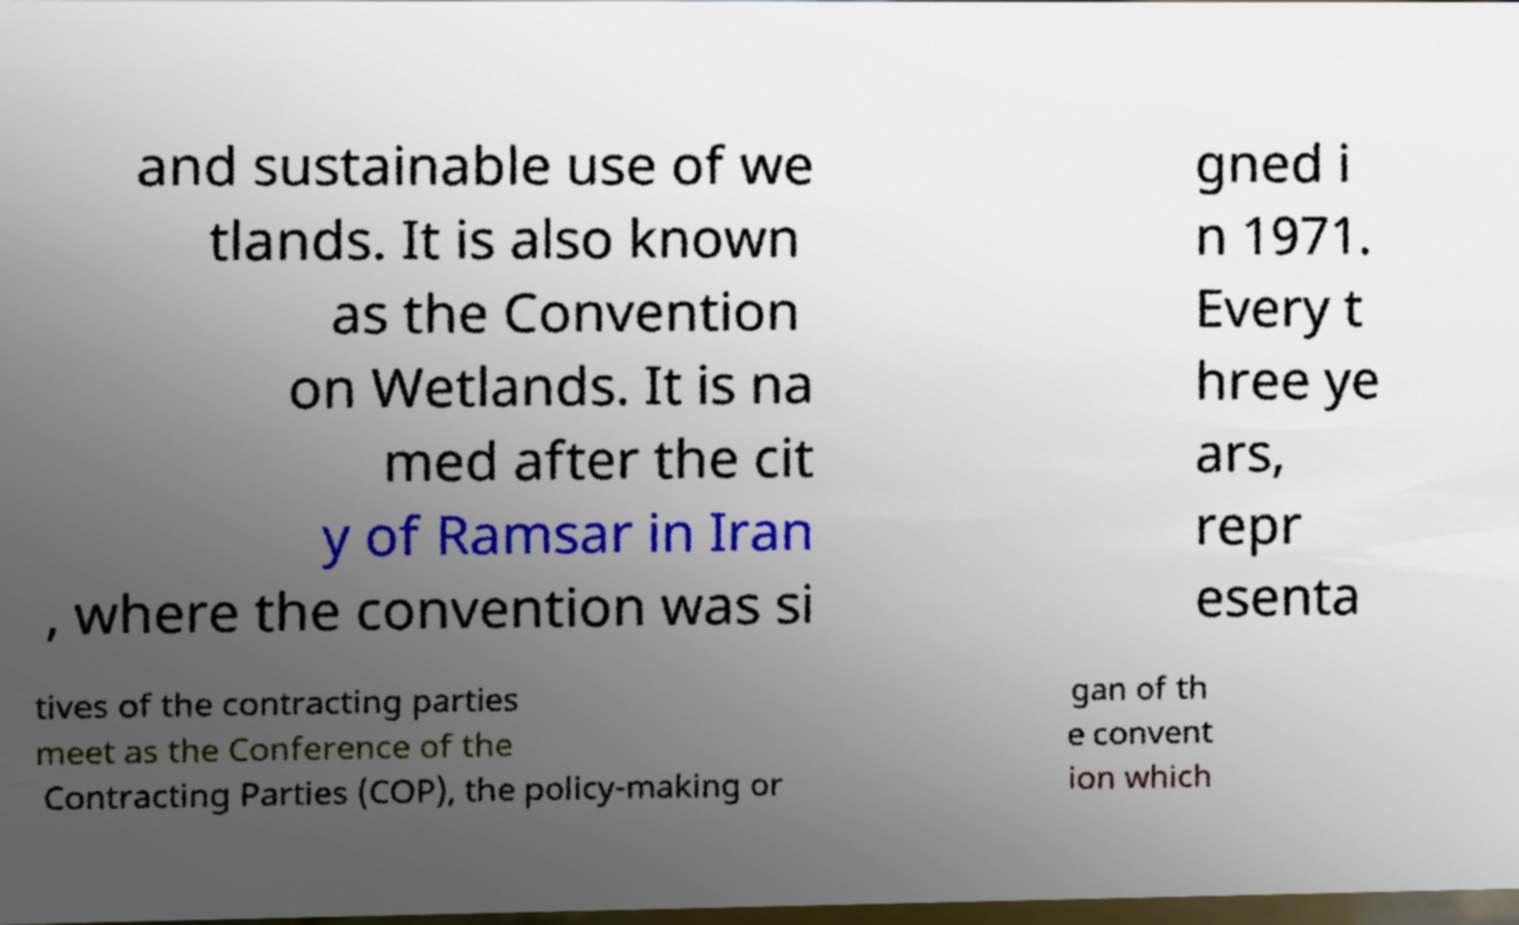Please identify and transcribe the text found in this image. and sustainable use of we tlands. It is also known as the Convention on Wetlands. It is na med after the cit y of Ramsar in Iran , where the convention was si gned i n 1971. Every t hree ye ars, repr esenta tives of the contracting parties meet as the Conference of the Contracting Parties (COP), the policy-making or gan of th e convent ion which 